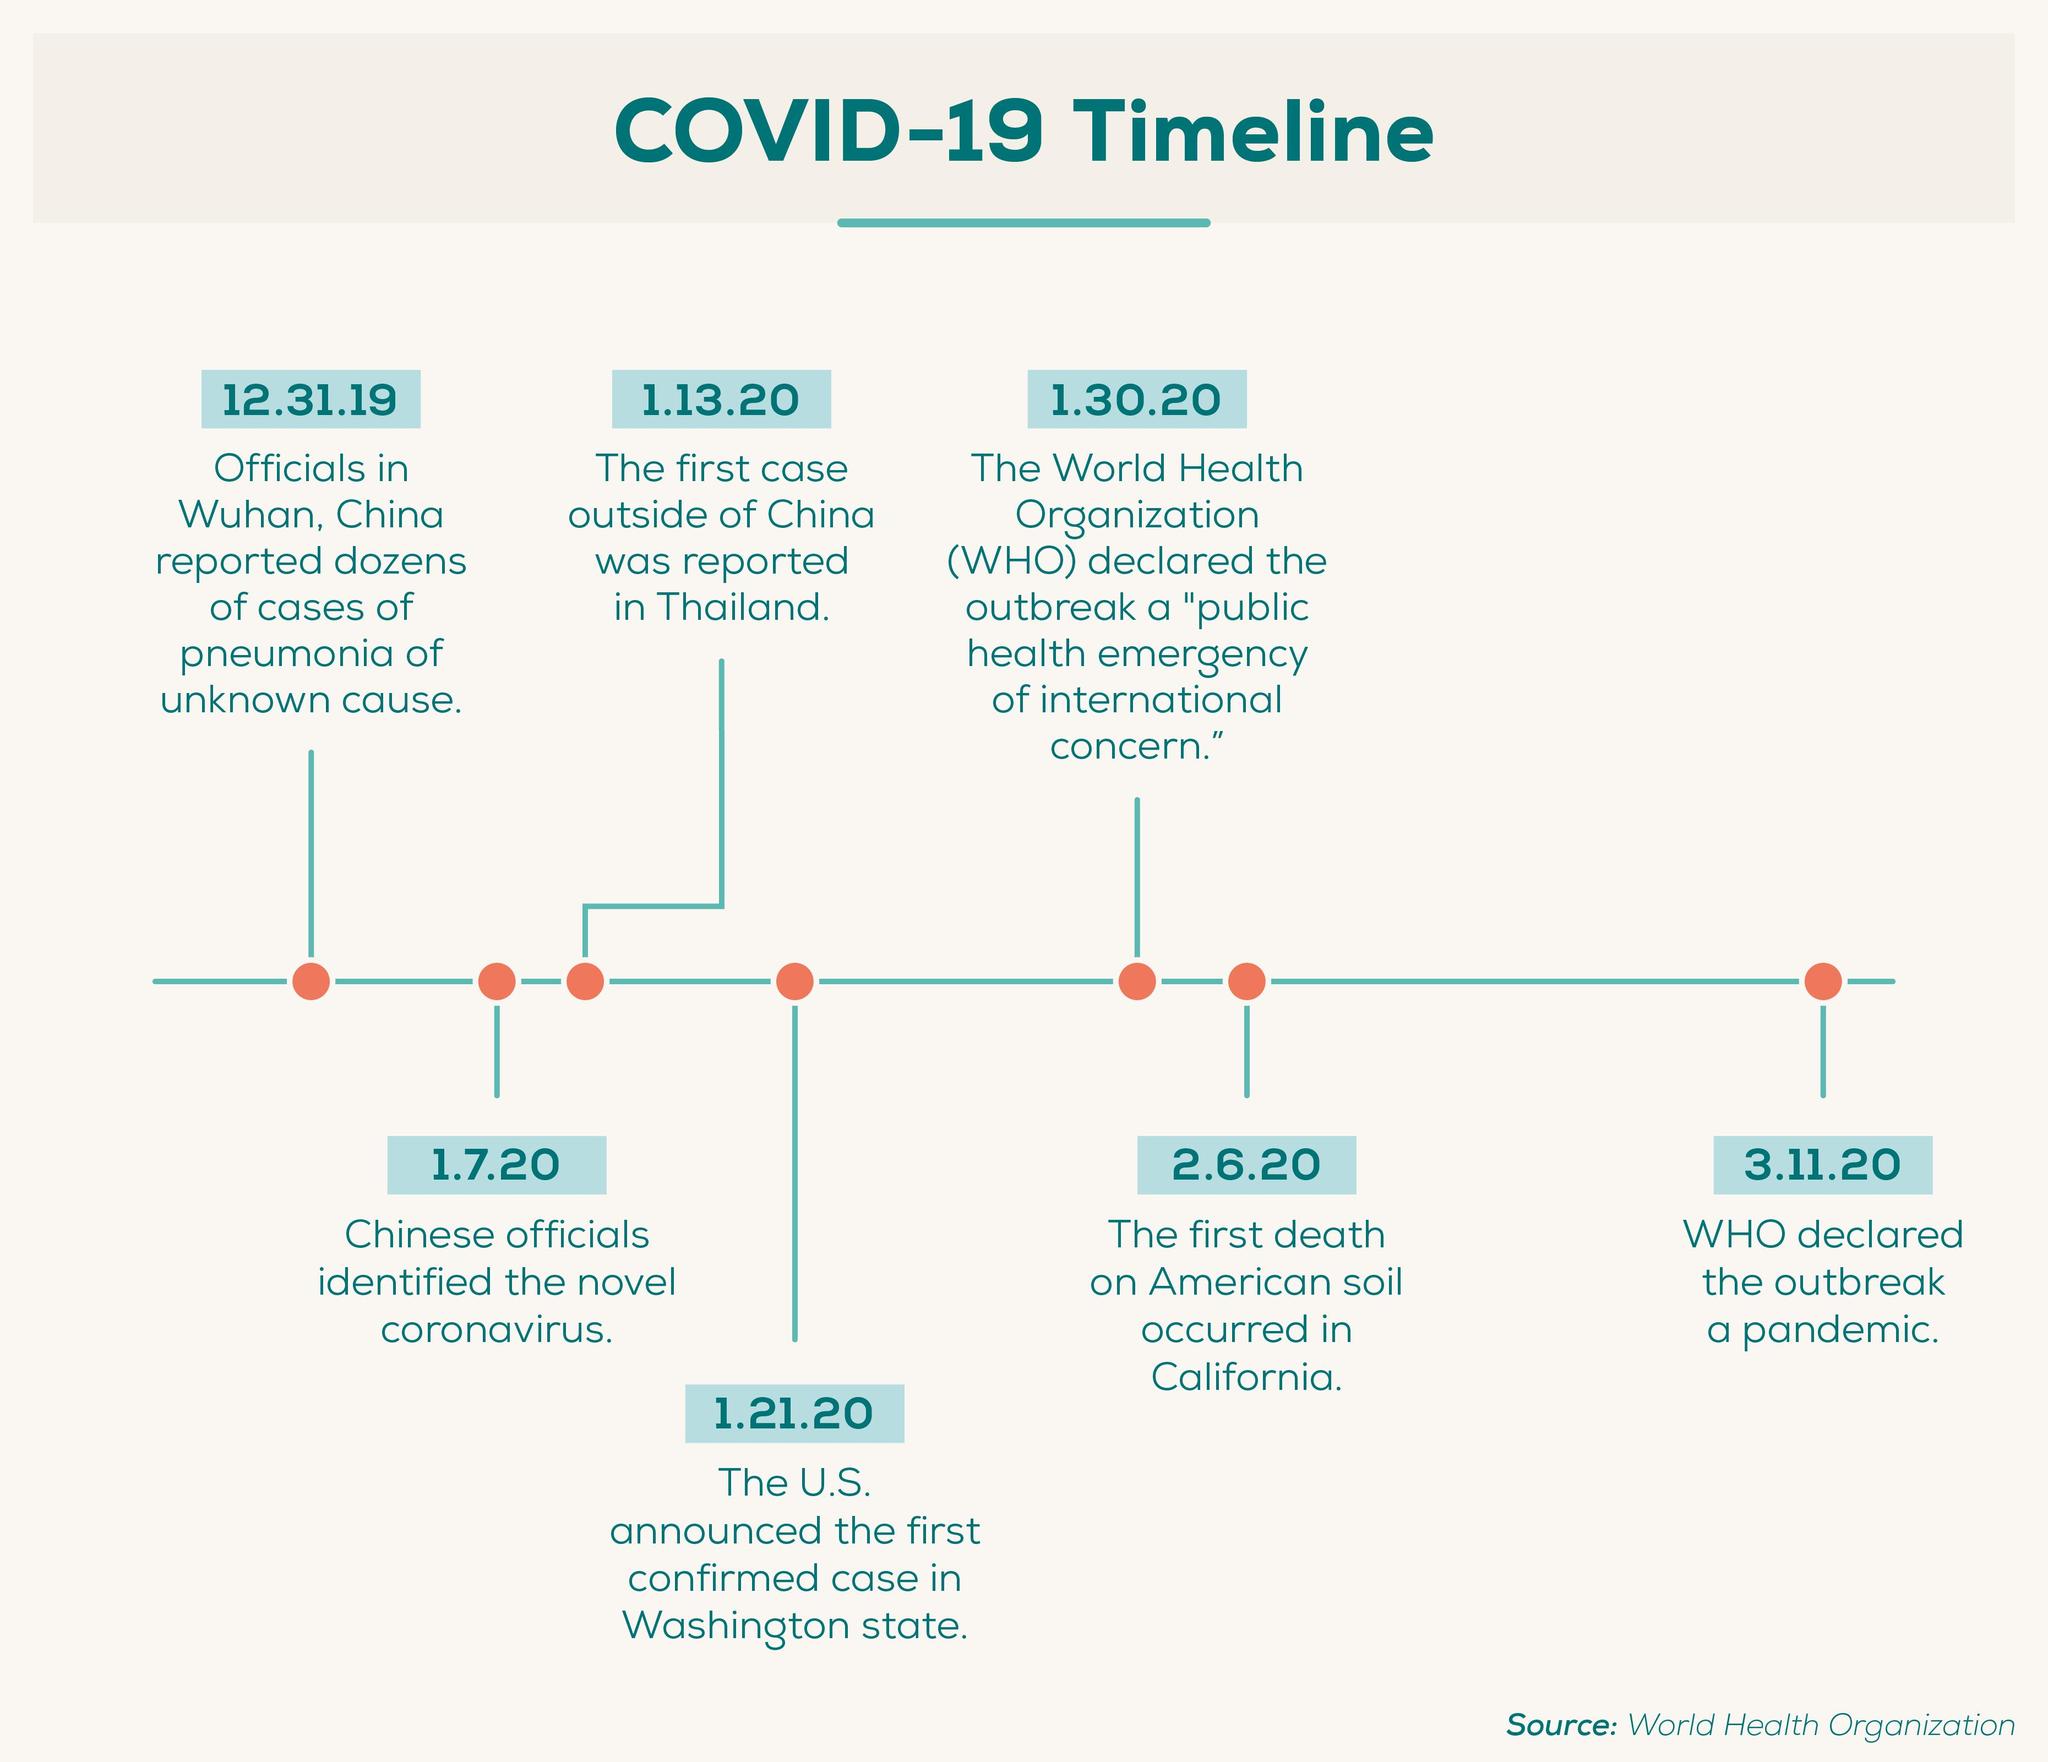Point out several critical features in this image. On January 7th, Chinese officials identified the novel coronavirus. On March 11, 2020, the World Health Organization declared the coronavirus disease 2019 (COVID-19) pandemic. The first confirmed case of COVID-19 outside of China was reported in Thailand. 